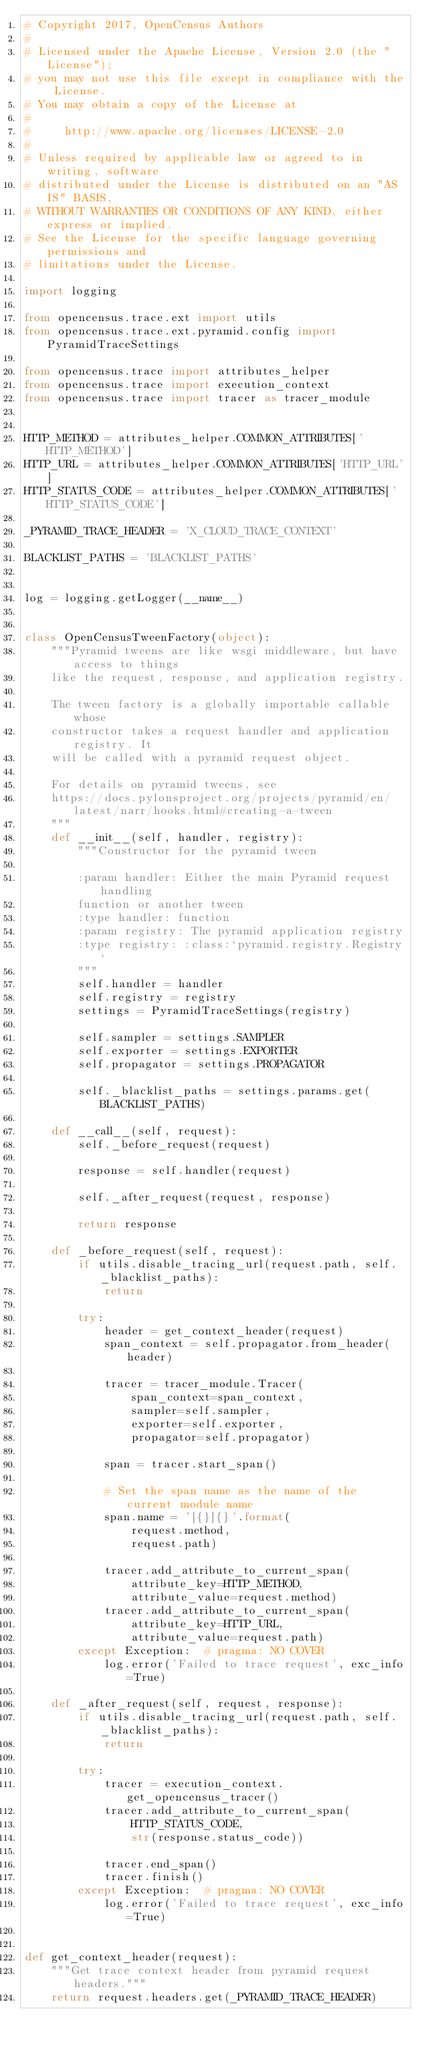<code> <loc_0><loc_0><loc_500><loc_500><_Python_># Copyright 2017, OpenCensus Authors
#
# Licensed under the Apache License, Version 2.0 (the "License");
# you may not use this file except in compliance with the License.
# You may obtain a copy of the License at
#
#     http://www.apache.org/licenses/LICENSE-2.0
#
# Unless required by applicable law or agreed to in writing, software
# distributed under the License is distributed on an "AS IS" BASIS,
# WITHOUT WARRANTIES OR CONDITIONS OF ANY KIND, either express or implied.
# See the License for the specific language governing permissions and
# limitations under the License.

import logging

from opencensus.trace.ext import utils
from opencensus.trace.ext.pyramid.config import PyramidTraceSettings

from opencensus.trace import attributes_helper
from opencensus.trace import execution_context
from opencensus.trace import tracer as tracer_module


HTTP_METHOD = attributes_helper.COMMON_ATTRIBUTES['HTTP_METHOD']
HTTP_URL = attributes_helper.COMMON_ATTRIBUTES['HTTP_URL']
HTTP_STATUS_CODE = attributes_helper.COMMON_ATTRIBUTES['HTTP_STATUS_CODE']

_PYRAMID_TRACE_HEADER = 'X_CLOUD_TRACE_CONTEXT'

BLACKLIST_PATHS = 'BLACKLIST_PATHS'


log = logging.getLogger(__name__)


class OpenCensusTweenFactory(object):
    """Pyramid tweens are like wsgi middleware, but have access to things
    like the request, response, and application registry.

    The tween factory is a globally importable callable whose
    constructor takes a request handler and application registry. It
    will be called with a pyramid request object.

    For details on pyramid tweens, see
    https://docs.pylonsproject.org/projects/pyramid/en/latest/narr/hooks.html#creating-a-tween
    """
    def __init__(self, handler, registry):
        """Constructor for the pyramid tween

        :param handler: Either the main Pyramid request handling
        function or another tween
        :type handler: function
        :param registry: The pyramid application registry
        :type registry: :class:`pyramid.registry.Registry`
        """
        self.handler = handler
        self.registry = registry
        settings = PyramidTraceSettings(registry)

        self.sampler = settings.SAMPLER
        self.exporter = settings.EXPORTER
        self.propagator = settings.PROPAGATOR

        self._blacklist_paths = settings.params.get(BLACKLIST_PATHS)

    def __call__(self, request):
        self._before_request(request)

        response = self.handler(request)

        self._after_request(request, response)

        return response

    def _before_request(self, request):
        if utils.disable_tracing_url(request.path, self._blacklist_paths):
            return

        try:
            header = get_context_header(request)
            span_context = self.propagator.from_header(header)

            tracer = tracer_module.Tracer(
                span_context=span_context,
                sampler=self.sampler,
                exporter=self.exporter,
                propagator=self.propagator)

            span = tracer.start_span()

            # Set the span name as the name of the current module name
            span.name = '[{}]{}'.format(
                request.method,
                request.path)

            tracer.add_attribute_to_current_span(
                attribute_key=HTTP_METHOD,
                attribute_value=request.method)
            tracer.add_attribute_to_current_span(
                attribute_key=HTTP_URL,
                attribute_value=request.path)
        except Exception:  # pragma: NO COVER
            log.error('Failed to trace request', exc_info=True)

    def _after_request(self, request, response):
        if utils.disable_tracing_url(request.path, self._blacklist_paths):
            return

        try:
            tracer = execution_context.get_opencensus_tracer()
            tracer.add_attribute_to_current_span(
                HTTP_STATUS_CODE,
                str(response.status_code))

            tracer.end_span()
            tracer.finish()
        except Exception:  # pragma: NO COVER
            log.error('Failed to trace request', exc_info=True)


def get_context_header(request):
    """Get trace context header from pyramid request headers."""
    return request.headers.get(_PYRAMID_TRACE_HEADER)
</code> 